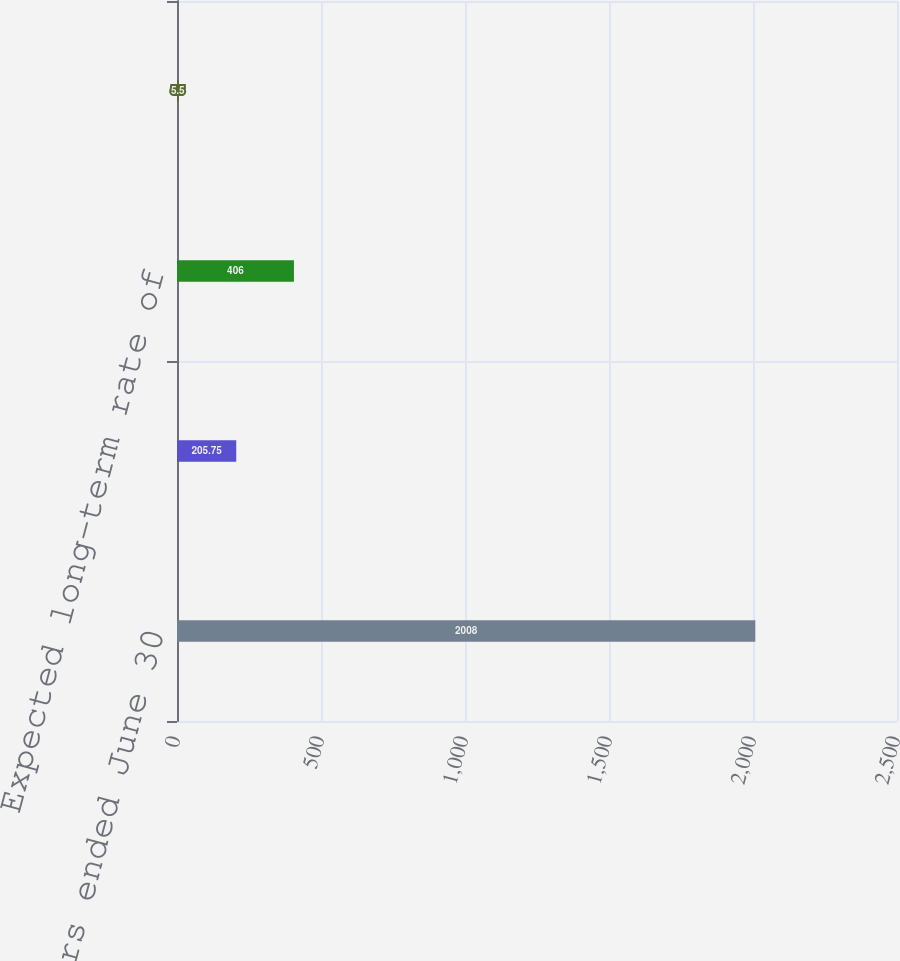<chart> <loc_0><loc_0><loc_500><loc_500><bar_chart><fcel>Years ended June 30<fcel>Discount rate<fcel>Expected long-term rate of<fcel>Increase in compensation<nl><fcel>2008<fcel>205.75<fcel>406<fcel>5.5<nl></chart> 